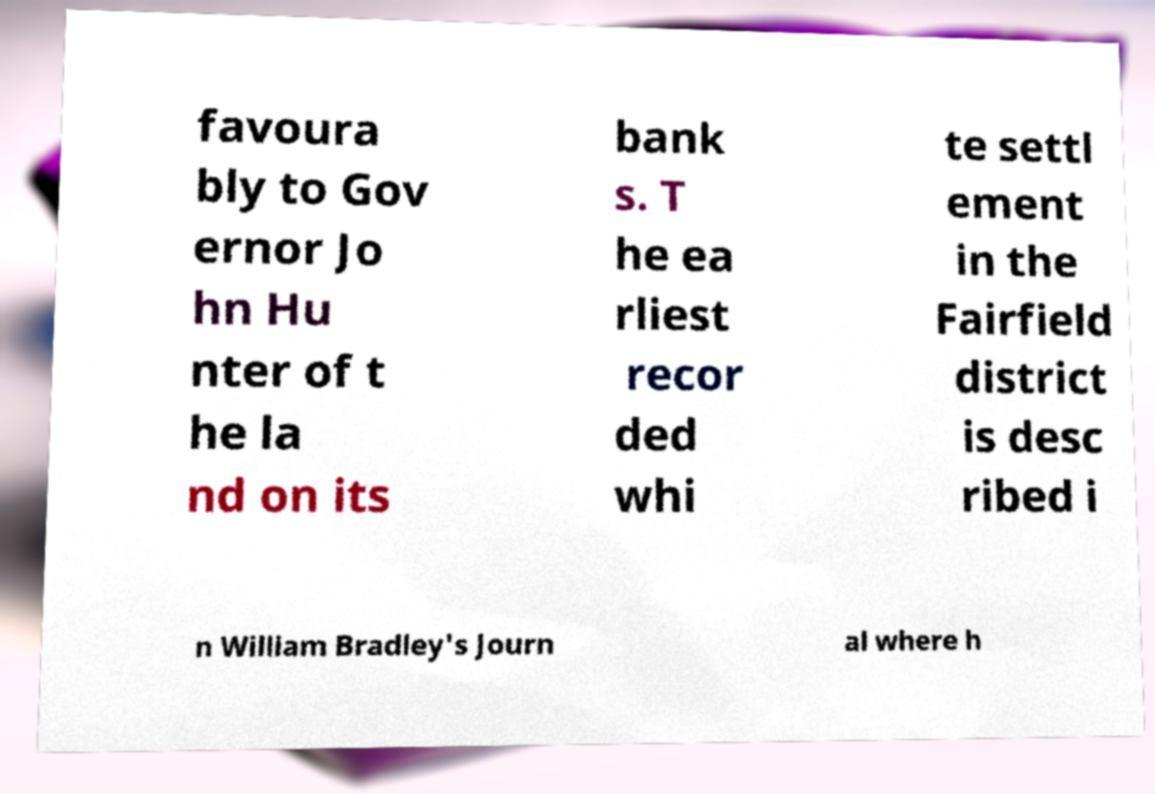Could you extract and type out the text from this image? favoura bly to Gov ernor Jo hn Hu nter of t he la nd on its bank s. T he ea rliest recor ded whi te settl ement in the Fairfield district is desc ribed i n William Bradley's Journ al where h 